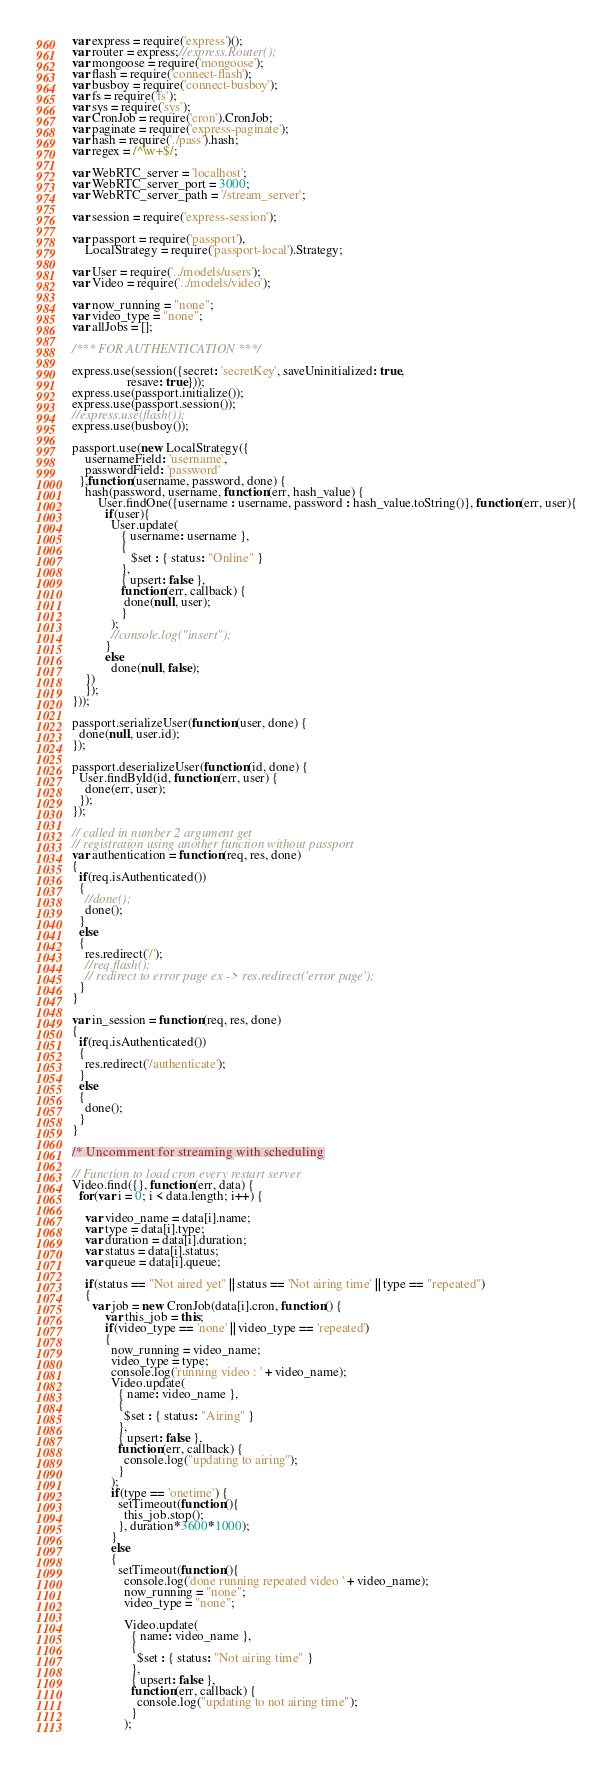<code> <loc_0><loc_0><loc_500><loc_500><_JavaScript_>var express = require('express')();
var router = express;//express.Router();
var mongoose = require('mongoose');
var flash = require('connect-flash');
var busboy = require('connect-busboy');
var fs = require('fs');
var sys = require('sys');
var CronJob = require('cron').CronJob;
var paginate = require('express-paginate');
var hash = require('./pass').hash;
var regex = /^\w+$/;

var WebRTC_server = 'localhost';
var WebRTC_server_port = 3000;
var WebRTC_server_path = '/stream_server';

var session = require('express-session');

var passport = require('passport'),
    LocalStrategy = require('passport-local').Strategy;

var User = require('../models/users');
var Video = require('../models/video');

var now_running = "none";
var video_type = "none";
var allJobs = [];

/*** FOR AUTHENTICATION ***/

express.use(session({secret: 'secretKey', saveUninitialized: true,
                 resave: true}));
express.use(passport.initialize());
express.use(passport.session());
//express.use(flash());
express.use(busboy());

passport.use(new LocalStrategy({
    usernameField: 'username',
    passwordField: 'password'
  },function(username, password, done) {
    hash(password, username, function(err, hash_value) {
        User.findOne({username : username, password : hash_value.toString()}, function(err, user){
          if(user){
            User.update(
               { username: username },
               {
                  $set : { status: "Online" }    
               },
               { upsert: false },
               function(err, callback) {
                done(null, user);
               } 
            );
            //console.log("insert");
          }
          else
            done(null, false);
    })
	});
}));

passport.serializeUser(function(user, done) {
  done(null, user.id);
});

passport.deserializeUser(function(id, done) {
  User.findById(id, function(err, user) {
    done(err, user);
  });
});

// called in number 2 argument get
// registration using another function without passport
var authentication = function(req, res, done) 
{
  if(req.isAuthenticated())
  {
    //done();
  	done();
  }
  else
  {
  	res.redirect('/');
    //req.flash();
    // redirect to error page ex -> res.redirect('error page');
  }
}

var in_session = function(req, res, done) 
{
  if(req.isAuthenticated())
  {
    res.redirect('/authenticate');
  }
  else
  {
    done();
  }
}

/* Uncomment for streaming with scheduling

// Function to load cron every restart server
Video.find({}, function(err, data) {
  for(var i = 0; i < data.length; i++) {

    var video_name = data[i].name;
    var type = data[i].type;
    var duration = data[i].duration;
    var status = data[i].status;
    var queue = data[i].queue;

    if(status == "Not aired yet" || status == 'Not airing time' || type == "repeated")
    {
      var job = new CronJob(data[i].cron, function() {
          var this_job = this;
          if(video_type == 'none' || video_type == 'repeated')
          {
            now_running = video_name;
            video_type = type;
            console.log('running video : ' + video_name);
            Video.update(
              { name: video_name },
              {
                $set : { status: "Airing" }    
              },
              { upsert: false },
              function(err, callback) {
                console.log("updating to airing");
              } 
            );
            if(type == 'onetime') {
              setTimeout(function(){
                this_job.stop();
              }, duration*3600*1000);
            }
            else
            {
              setTimeout(function(){
                console.log('done running repeated video ' + video_name);
                now_running = "none";
                video_type = "none";

                Video.update(
                  { name: video_name },
                  {
                    $set : { status: "Not airing time" }    
                  },
                  { upsert: false },
                  function(err, callback) {
                    console.log("updating to not airing time");
                  } 
                );</code> 